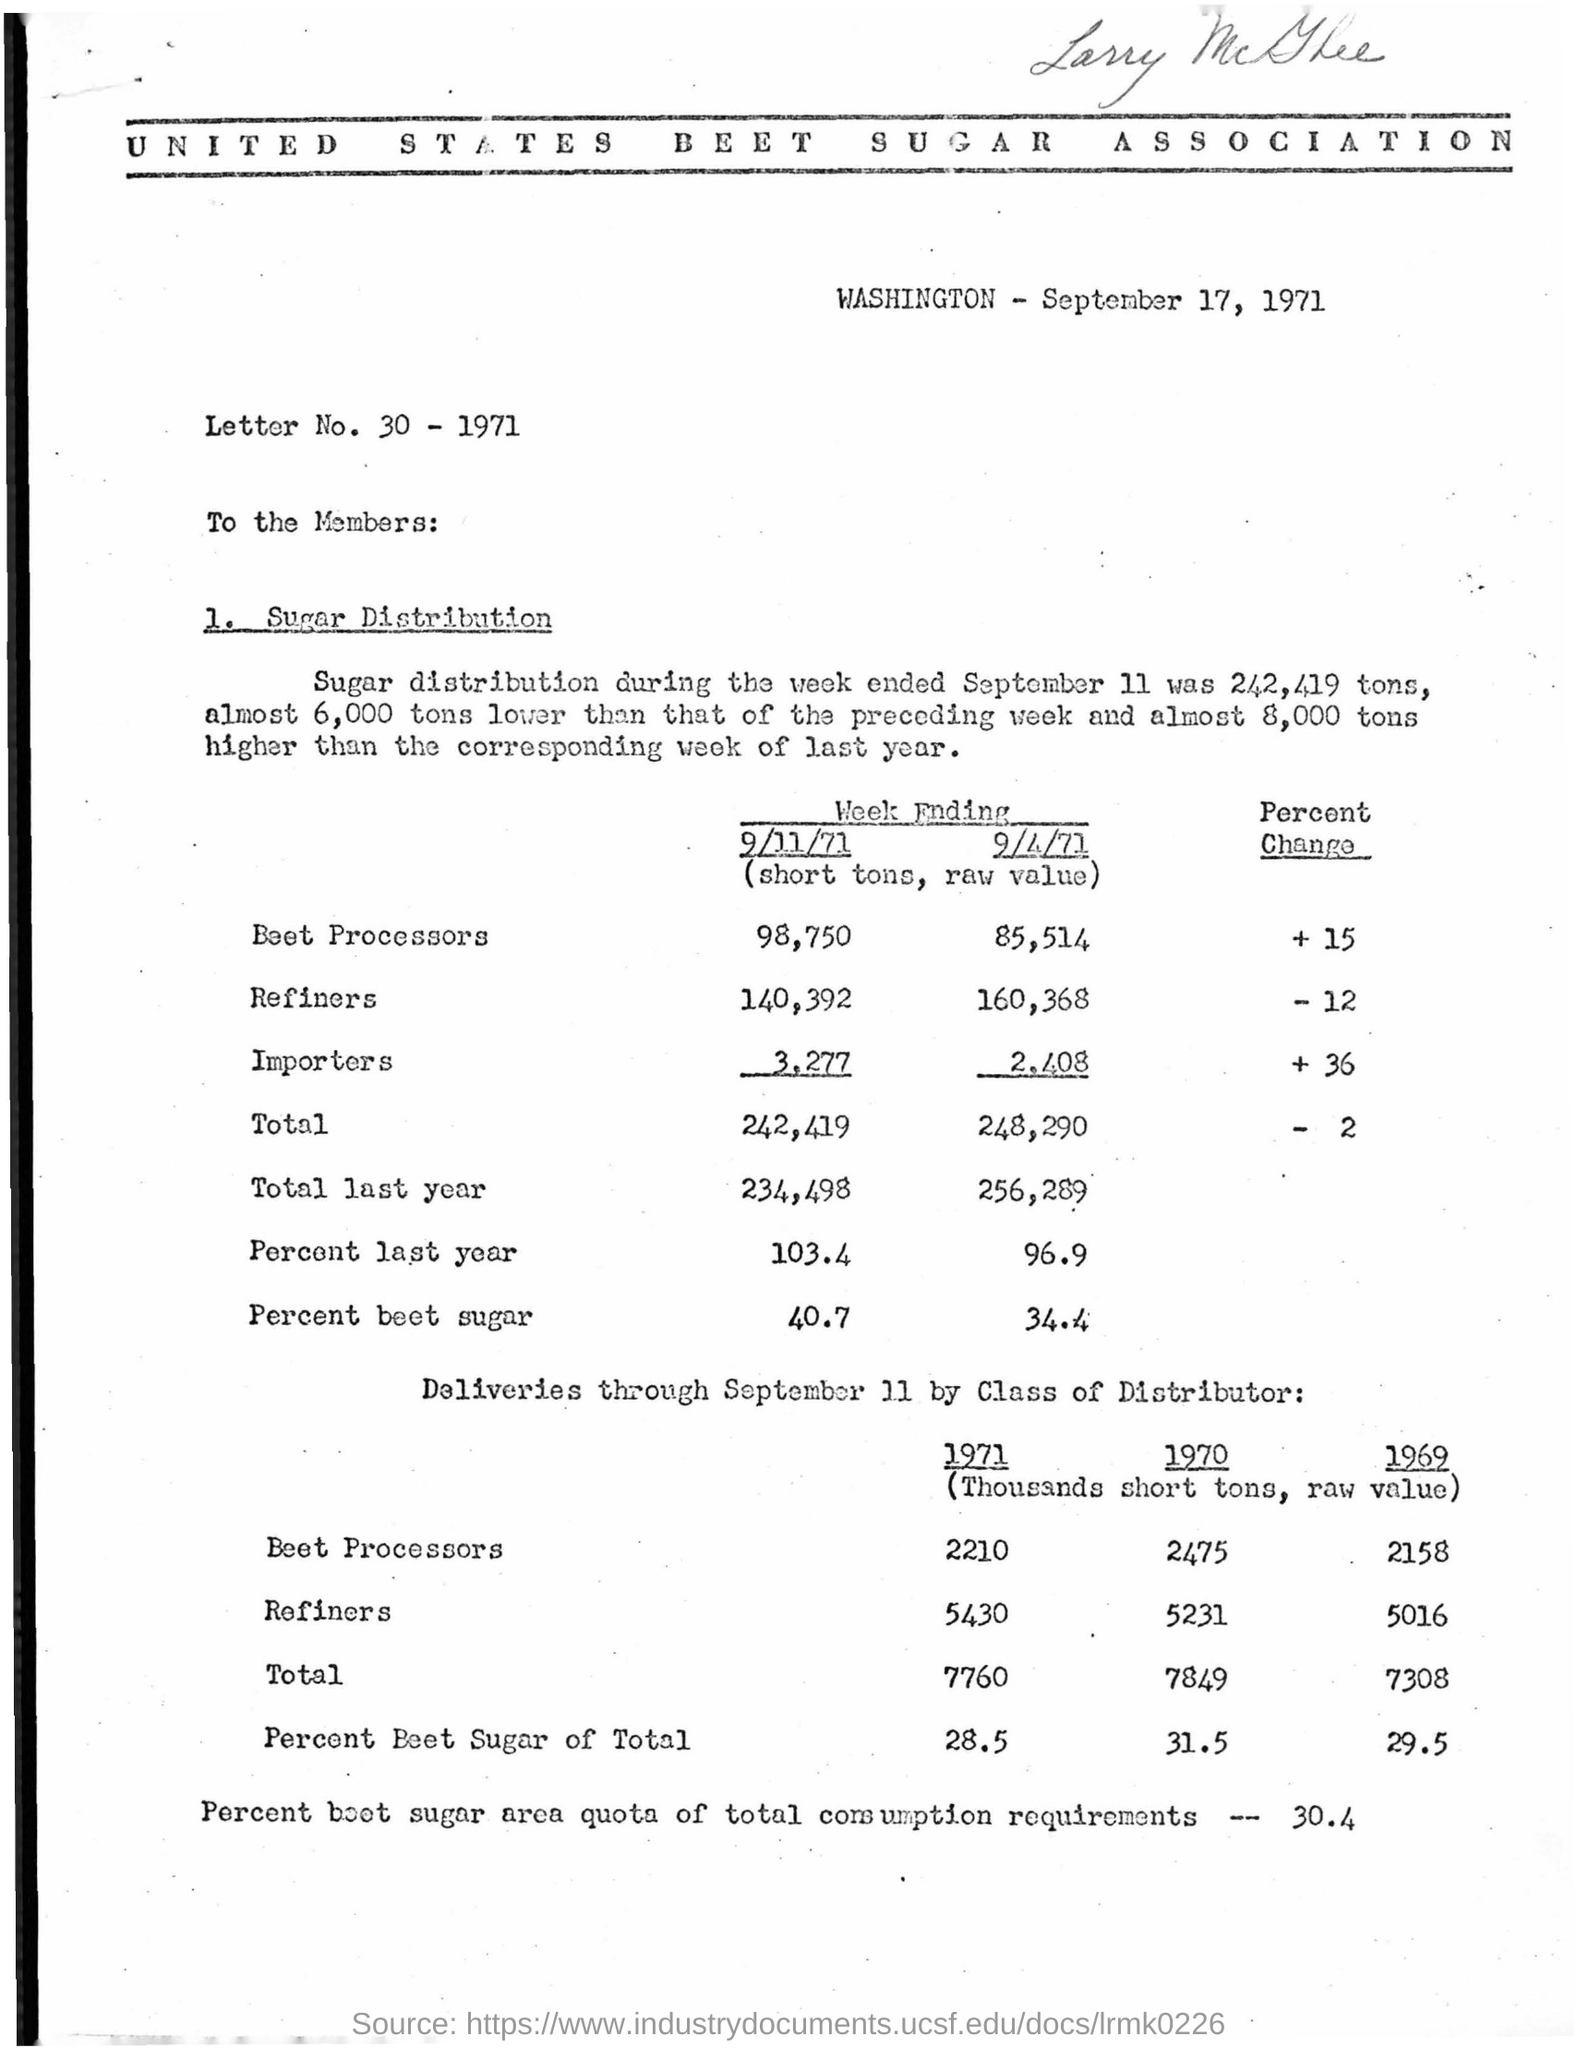Highlight a few significant elements in this photo. The date on which the letter was issued is September 17, 1971. The letter number is 30. It is obtained by subtracting 1971 from it. 